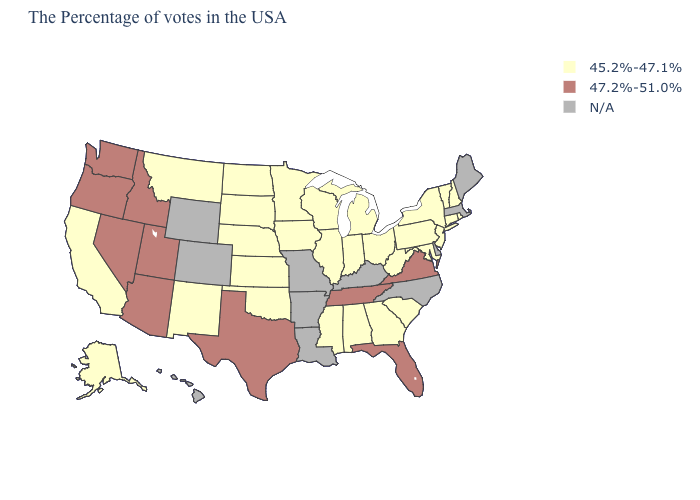Name the states that have a value in the range 45.2%-47.1%?
Keep it brief. Rhode Island, New Hampshire, Vermont, Connecticut, New York, New Jersey, Maryland, Pennsylvania, South Carolina, West Virginia, Ohio, Georgia, Michigan, Indiana, Alabama, Wisconsin, Illinois, Mississippi, Minnesota, Iowa, Kansas, Nebraska, Oklahoma, South Dakota, North Dakota, New Mexico, Montana, California, Alaska. What is the value of Wisconsin?
Quick response, please. 45.2%-47.1%. What is the value of Arizona?
Concise answer only. 47.2%-51.0%. Does the first symbol in the legend represent the smallest category?
Give a very brief answer. Yes. Which states have the highest value in the USA?
Concise answer only. Virginia, Florida, Tennessee, Texas, Utah, Arizona, Idaho, Nevada, Washington, Oregon. Does the first symbol in the legend represent the smallest category?
Concise answer only. Yes. Name the states that have a value in the range N/A?
Give a very brief answer. Maine, Massachusetts, Delaware, North Carolina, Kentucky, Louisiana, Missouri, Arkansas, Wyoming, Colorado, Hawaii. Name the states that have a value in the range N/A?
Short answer required. Maine, Massachusetts, Delaware, North Carolina, Kentucky, Louisiana, Missouri, Arkansas, Wyoming, Colorado, Hawaii. What is the value of Tennessee?
Be succinct. 47.2%-51.0%. What is the value of Florida?
Give a very brief answer. 47.2%-51.0%. What is the highest value in the West ?
Concise answer only. 47.2%-51.0%. What is the highest value in the USA?
Answer briefly. 47.2%-51.0%. What is the value of Wisconsin?
Short answer required. 45.2%-47.1%. Which states hav the highest value in the MidWest?
Quick response, please. Ohio, Michigan, Indiana, Wisconsin, Illinois, Minnesota, Iowa, Kansas, Nebraska, South Dakota, North Dakota. 